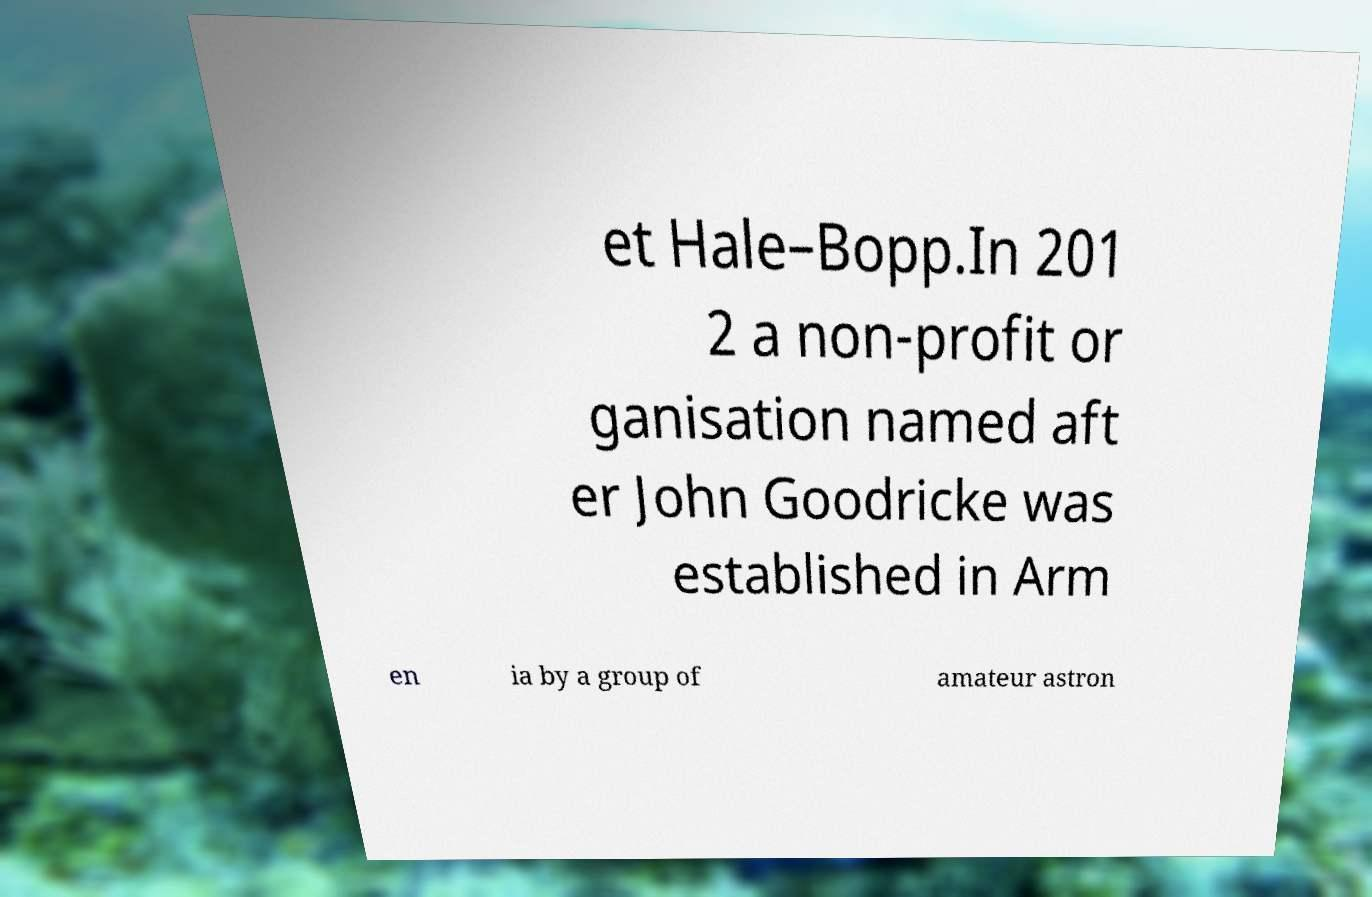Please read and relay the text visible in this image. What does it say? et Hale–Bopp.In 201 2 a non-profit or ganisation named aft er John Goodricke was established in Arm en ia by a group of amateur astron 